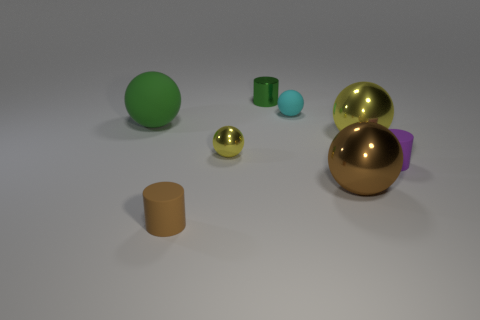What shape is the yellow thing to the right of the brown thing that is to the right of the tiny cyan rubber thing?
Give a very brief answer. Sphere. There is a rubber object in front of the cylinder right of the rubber sphere that is right of the tiny brown cylinder; how big is it?
Keep it short and to the point. Small. Is the size of the cyan thing the same as the purple matte cylinder?
Give a very brief answer. Yes. How many things are tiny brown cylinders or big green matte spheres?
Your answer should be compact. 2. There is a ball behind the ball that is on the left side of the brown cylinder; what is its size?
Provide a succinct answer. Small. The metal cylinder is what size?
Your response must be concise. Small. What is the shape of the small thing that is both left of the small green thing and on the right side of the tiny brown object?
Keep it short and to the point. Sphere. What color is the other large metal object that is the same shape as the big brown thing?
Provide a succinct answer. Yellow. What number of things are things that are to the right of the large brown ball or spheres that are behind the tiny purple matte cylinder?
Provide a short and direct response. 5. What is the shape of the green matte thing?
Keep it short and to the point. Sphere. 